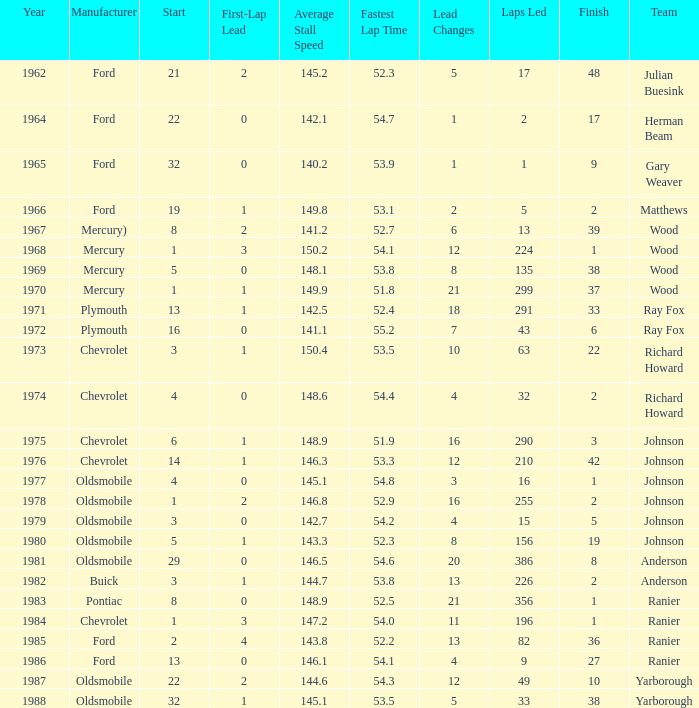Who was the maufacturer of the vehicle during the race where Cale Yarborough started at 19 and finished earlier than 42? Ford. 